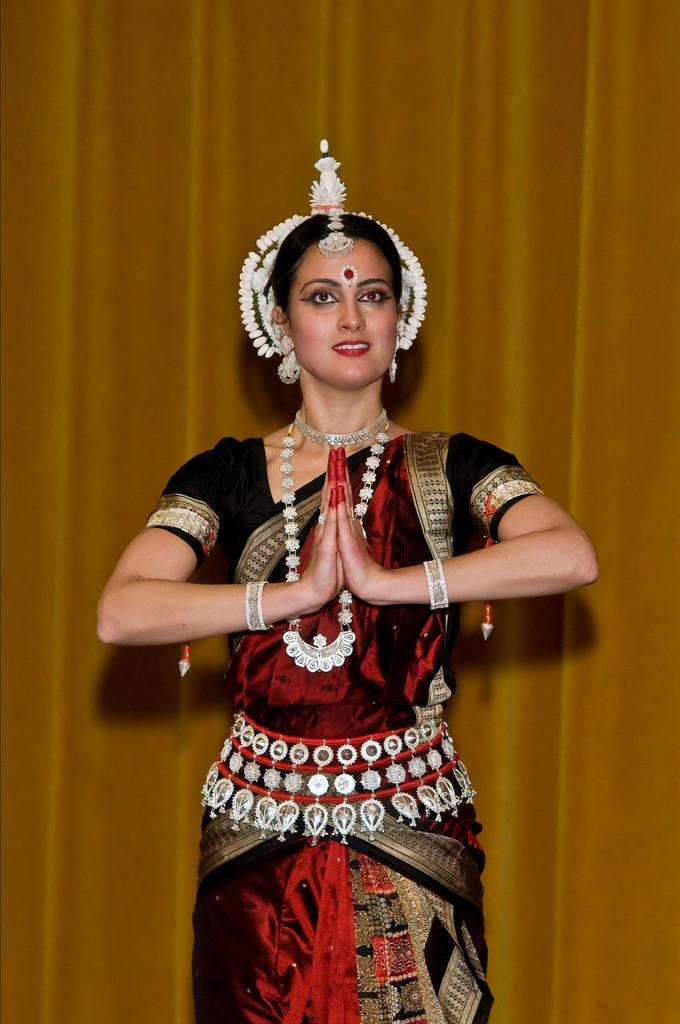What is the main subject of the image? There is a woman standing in the image. What is the woman wearing in the image? The woman is wearing ornaments in the image. What else can be seen in the background of the image? There is a curtain visible in the image. What type of title can be seen on the woman's head in the image? There is no title visible on the woman's head in the image. How many cobwebs are present on the curtain in the image? There are no cobwebs present on the curtain in the image. 